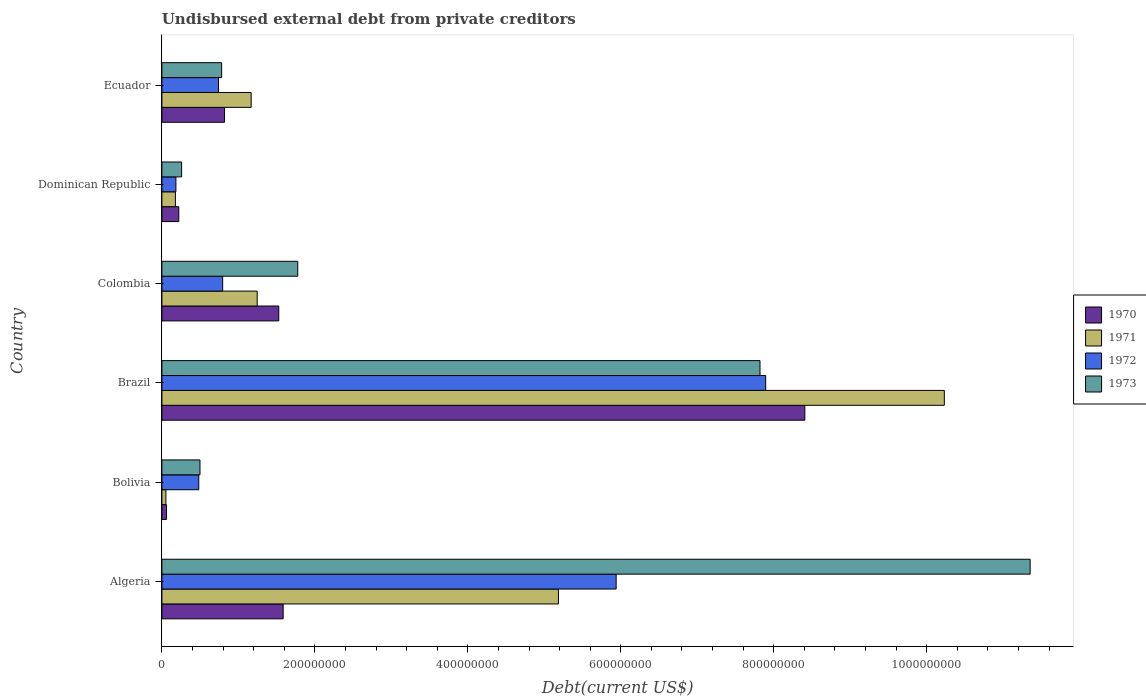Are the number of bars on each tick of the Y-axis equal?
Give a very brief answer. Yes. How many bars are there on the 4th tick from the top?
Make the answer very short. 4. What is the label of the 1st group of bars from the top?
Ensure brevity in your answer.  Ecuador. What is the total debt in 1972 in Dominican Republic?
Your answer should be compact. 1.83e+07. Across all countries, what is the maximum total debt in 1973?
Provide a short and direct response. 1.14e+09. Across all countries, what is the minimum total debt in 1970?
Ensure brevity in your answer.  6.05e+06. In which country was the total debt in 1973 maximum?
Make the answer very short. Algeria. In which country was the total debt in 1973 minimum?
Keep it short and to the point. Dominican Republic. What is the total total debt in 1973 in the graph?
Your response must be concise. 2.25e+09. What is the difference between the total debt in 1973 in Brazil and that in Colombia?
Make the answer very short. 6.04e+08. What is the difference between the total debt in 1973 in Ecuador and the total debt in 1972 in Algeria?
Make the answer very short. -5.16e+08. What is the average total debt in 1970 per country?
Provide a succinct answer. 2.10e+08. What is the difference between the total debt in 1972 and total debt in 1973 in Algeria?
Provide a succinct answer. -5.41e+08. In how many countries, is the total debt in 1972 greater than 240000000 US$?
Your answer should be compact. 2. What is the ratio of the total debt in 1973 in Brazil to that in Dominican Republic?
Give a very brief answer. 30.34. Is the total debt in 1970 in Brazil less than that in Ecuador?
Keep it short and to the point. No. What is the difference between the highest and the second highest total debt in 1971?
Provide a short and direct response. 5.05e+08. What is the difference between the highest and the lowest total debt in 1970?
Provide a short and direct response. 8.35e+08. Is the sum of the total debt in 1972 in Colombia and Dominican Republic greater than the maximum total debt in 1970 across all countries?
Offer a very short reply. No. Is it the case that in every country, the sum of the total debt in 1970 and total debt in 1971 is greater than the sum of total debt in 1972 and total debt in 1973?
Your answer should be compact. No. What does the 3rd bar from the top in Algeria represents?
Give a very brief answer. 1971. How many bars are there?
Ensure brevity in your answer.  24. Are all the bars in the graph horizontal?
Your response must be concise. Yes. How many countries are there in the graph?
Your answer should be compact. 6. Are the values on the major ticks of X-axis written in scientific E-notation?
Offer a very short reply. No. Does the graph contain any zero values?
Your answer should be very brief. No. Does the graph contain grids?
Your response must be concise. No. Where does the legend appear in the graph?
Your response must be concise. Center right. What is the title of the graph?
Provide a short and direct response. Undisbursed external debt from private creditors. What is the label or title of the X-axis?
Ensure brevity in your answer.  Debt(current US$). What is the label or title of the Y-axis?
Provide a short and direct response. Country. What is the Debt(current US$) of 1970 in Algeria?
Provide a succinct answer. 1.59e+08. What is the Debt(current US$) in 1971 in Algeria?
Provide a succinct answer. 5.18e+08. What is the Debt(current US$) of 1972 in Algeria?
Make the answer very short. 5.94e+08. What is the Debt(current US$) of 1973 in Algeria?
Offer a terse response. 1.14e+09. What is the Debt(current US$) in 1970 in Bolivia?
Provide a short and direct response. 6.05e+06. What is the Debt(current US$) of 1971 in Bolivia?
Offer a very short reply. 5.25e+06. What is the Debt(current US$) in 1972 in Bolivia?
Keep it short and to the point. 4.82e+07. What is the Debt(current US$) of 1973 in Bolivia?
Make the answer very short. 4.98e+07. What is the Debt(current US$) of 1970 in Brazil?
Offer a terse response. 8.41e+08. What is the Debt(current US$) of 1971 in Brazil?
Offer a terse response. 1.02e+09. What is the Debt(current US$) in 1972 in Brazil?
Ensure brevity in your answer.  7.89e+08. What is the Debt(current US$) in 1973 in Brazil?
Provide a short and direct response. 7.82e+08. What is the Debt(current US$) of 1970 in Colombia?
Your answer should be very brief. 1.53e+08. What is the Debt(current US$) of 1971 in Colombia?
Offer a very short reply. 1.25e+08. What is the Debt(current US$) of 1972 in Colombia?
Make the answer very short. 7.95e+07. What is the Debt(current US$) of 1973 in Colombia?
Provide a succinct answer. 1.78e+08. What is the Debt(current US$) in 1970 in Dominican Republic?
Your answer should be compact. 2.21e+07. What is the Debt(current US$) of 1971 in Dominican Republic?
Provide a succinct answer. 1.76e+07. What is the Debt(current US$) in 1972 in Dominican Republic?
Offer a very short reply. 1.83e+07. What is the Debt(current US$) of 1973 in Dominican Republic?
Give a very brief answer. 2.58e+07. What is the Debt(current US$) of 1970 in Ecuador?
Your answer should be compact. 8.19e+07. What is the Debt(current US$) of 1971 in Ecuador?
Ensure brevity in your answer.  1.17e+08. What is the Debt(current US$) of 1972 in Ecuador?
Provide a short and direct response. 7.40e+07. What is the Debt(current US$) in 1973 in Ecuador?
Make the answer very short. 7.81e+07. Across all countries, what is the maximum Debt(current US$) in 1970?
Offer a terse response. 8.41e+08. Across all countries, what is the maximum Debt(current US$) of 1971?
Keep it short and to the point. 1.02e+09. Across all countries, what is the maximum Debt(current US$) of 1972?
Ensure brevity in your answer.  7.89e+08. Across all countries, what is the maximum Debt(current US$) in 1973?
Give a very brief answer. 1.14e+09. Across all countries, what is the minimum Debt(current US$) in 1970?
Offer a terse response. 6.05e+06. Across all countries, what is the minimum Debt(current US$) of 1971?
Give a very brief answer. 5.25e+06. Across all countries, what is the minimum Debt(current US$) of 1972?
Your response must be concise. 1.83e+07. Across all countries, what is the minimum Debt(current US$) in 1973?
Give a very brief answer. 2.58e+07. What is the total Debt(current US$) in 1970 in the graph?
Your answer should be very brief. 1.26e+09. What is the total Debt(current US$) in 1971 in the graph?
Offer a very short reply. 1.81e+09. What is the total Debt(current US$) of 1972 in the graph?
Make the answer very short. 1.60e+09. What is the total Debt(current US$) in 1973 in the graph?
Offer a terse response. 2.25e+09. What is the difference between the Debt(current US$) in 1970 in Algeria and that in Bolivia?
Offer a very short reply. 1.53e+08. What is the difference between the Debt(current US$) in 1971 in Algeria and that in Bolivia?
Give a very brief answer. 5.13e+08. What is the difference between the Debt(current US$) of 1972 in Algeria and that in Bolivia?
Provide a short and direct response. 5.46e+08. What is the difference between the Debt(current US$) of 1973 in Algeria and that in Bolivia?
Your answer should be very brief. 1.09e+09. What is the difference between the Debt(current US$) in 1970 in Algeria and that in Brazil?
Ensure brevity in your answer.  -6.82e+08. What is the difference between the Debt(current US$) of 1971 in Algeria and that in Brazil?
Give a very brief answer. -5.05e+08. What is the difference between the Debt(current US$) in 1972 in Algeria and that in Brazil?
Provide a succinct answer. -1.95e+08. What is the difference between the Debt(current US$) of 1973 in Algeria and that in Brazil?
Offer a very short reply. 3.53e+08. What is the difference between the Debt(current US$) of 1970 in Algeria and that in Colombia?
Your response must be concise. 5.77e+06. What is the difference between the Debt(current US$) of 1971 in Algeria and that in Colombia?
Offer a terse response. 3.94e+08. What is the difference between the Debt(current US$) of 1972 in Algeria and that in Colombia?
Ensure brevity in your answer.  5.14e+08. What is the difference between the Debt(current US$) of 1973 in Algeria and that in Colombia?
Your response must be concise. 9.58e+08. What is the difference between the Debt(current US$) of 1970 in Algeria and that in Dominican Republic?
Give a very brief answer. 1.36e+08. What is the difference between the Debt(current US$) in 1971 in Algeria and that in Dominican Republic?
Your answer should be compact. 5.01e+08. What is the difference between the Debt(current US$) in 1972 in Algeria and that in Dominican Republic?
Offer a very short reply. 5.76e+08. What is the difference between the Debt(current US$) in 1973 in Algeria and that in Dominican Republic?
Keep it short and to the point. 1.11e+09. What is the difference between the Debt(current US$) of 1970 in Algeria and that in Ecuador?
Keep it short and to the point. 7.67e+07. What is the difference between the Debt(current US$) of 1971 in Algeria and that in Ecuador?
Offer a terse response. 4.02e+08. What is the difference between the Debt(current US$) in 1972 in Algeria and that in Ecuador?
Provide a succinct answer. 5.20e+08. What is the difference between the Debt(current US$) in 1973 in Algeria and that in Ecuador?
Offer a terse response. 1.06e+09. What is the difference between the Debt(current US$) in 1970 in Bolivia and that in Brazil?
Provide a succinct answer. -8.35e+08. What is the difference between the Debt(current US$) of 1971 in Bolivia and that in Brazil?
Ensure brevity in your answer.  -1.02e+09. What is the difference between the Debt(current US$) of 1972 in Bolivia and that in Brazil?
Give a very brief answer. -7.41e+08. What is the difference between the Debt(current US$) in 1973 in Bolivia and that in Brazil?
Your answer should be compact. -7.32e+08. What is the difference between the Debt(current US$) in 1970 in Bolivia and that in Colombia?
Your answer should be compact. -1.47e+08. What is the difference between the Debt(current US$) in 1971 in Bolivia and that in Colombia?
Provide a succinct answer. -1.19e+08. What is the difference between the Debt(current US$) in 1972 in Bolivia and that in Colombia?
Keep it short and to the point. -3.13e+07. What is the difference between the Debt(current US$) of 1973 in Bolivia and that in Colombia?
Make the answer very short. -1.28e+08. What is the difference between the Debt(current US$) of 1970 in Bolivia and that in Dominican Republic?
Your answer should be very brief. -1.60e+07. What is the difference between the Debt(current US$) of 1971 in Bolivia and that in Dominican Republic?
Give a very brief answer. -1.24e+07. What is the difference between the Debt(current US$) in 1972 in Bolivia and that in Dominican Republic?
Offer a very short reply. 2.99e+07. What is the difference between the Debt(current US$) of 1973 in Bolivia and that in Dominican Republic?
Provide a succinct answer. 2.40e+07. What is the difference between the Debt(current US$) in 1970 in Bolivia and that in Ecuador?
Your answer should be very brief. -7.58e+07. What is the difference between the Debt(current US$) of 1971 in Bolivia and that in Ecuador?
Offer a very short reply. -1.11e+08. What is the difference between the Debt(current US$) of 1972 in Bolivia and that in Ecuador?
Your response must be concise. -2.58e+07. What is the difference between the Debt(current US$) of 1973 in Bolivia and that in Ecuador?
Ensure brevity in your answer.  -2.83e+07. What is the difference between the Debt(current US$) of 1970 in Brazil and that in Colombia?
Your response must be concise. 6.88e+08. What is the difference between the Debt(current US$) in 1971 in Brazil and that in Colombia?
Provide a short and direct response. 8.98e+08. What is the difference between the Debt(current US$) in 1972 in Brazil and that in Colombia?
Your answer should be compact. 7.10e+08. What is the difference between the Debt(current US$) of 1973 in Brazil and that in Colombia?
Provide a succinct answer. 6.04e+08. What is the difference between the Debt(current US$) in 1970 in Brazil and that in Dominican Republic?
Give a very brief answer. 8.19e+08. What is the difference between the Debt(current US$) in 1971 in Brazil and that in Dominican Republic?
Your answer should be very brief. 1.01e+09. What is the difference between the Debt(current US$) in 1972 in Brazil and that in Dominican Republic?
Your answer should be compact. 7.71e+08. What is the difference between the Debt(current US$) in 1973 in Brazil and that in Dominican Republic?
Offer a very short reply. 7.56e+08. What is the difference between the Debt(current US$) in 1970 in Brazil and that in Ecuador?
Your answer should be compact. 7.59e+08. What is the difference between the Debt(current US$) of 1971 in Brazil and that in Ecuador?
Give a very brief answer. 9.06e+08. What is the difference between the Debt(current US$) of 1972 in Brazil and that in Ecuador?
Provide a succinct answer. 7.15e+08. What is the difference between the Debt(current US$) of 1973 in Brazil and that in Ecuador?
Your answer should be very brief. 7.04e+08. What is the difference between the Debt(current US$) in 1970 in Colombia and that in Dominican Republic?
Your response must be concise. 1.31e+08. What is the difference between the Debt(current US$) in 1971 in Colombia and that in Dominican Republic?
Keep it short and to the point. 1.07e+08. What is the difference between the Debt(current US$) of 1972 in Colombia and that in Dominican Republic?
Your response must be concise. 6.12e+07. What is the difference between the Debt(current US$) in 1973 in Colombia and that in Dominican Republic?
Keep it short and to the point. 1.52e+08. What is the difference between the Debt(current US$) in 1970 in Colombia and that in Ecuador?
Your response must be concise. 7.09e+07. What is the difference between the Debt(current US$) in 1971 in Colombia and that in Ecuador?
Offer a terse response. 7.88e+06. What is the difference between the Debt(current US$) in 1972 in Colombia and that in Ecuador?
Your answer should be very brief. 5.49e+06. What is the difference between the Debt(current US$) of 1973 in Colombia and that in Ecuador?
Your response must be concise. 9.95e+07. What is the difference between the Debt(current US$) in 1970 in Dominican Republic and that in Ecuador?
Keep it short and to the point. -5.98e+07. What is the difference between the Debt(current US$) of 1971 in Dominican Republic and that in Ecuador?
Your response must be concise. -9.91e+07. What is the difference between the Debt(current US$) in 1972 in Dominican Republic and that in Ecuador?
Provide a succinct answer. -5.57e+07. What is the difference between the Debt(current US$) in 1973 in Dominican Republic and that in Ecuador?
Keep it short and to the point. -5.23e+07. What is the difference between the Debt(current US$) in 1970 in Algeria and the Debt(current US$) in 1971 in Bolivia?
Your answer should be very brief. 1.53e+08. What is the difference between the Debt(current US$) of 1970 in Algeria and the Debt(current US$) of 1972 in Bolivia?
Ensure brevity in your answer.  1.10e+08. What is the difference between the Debt(current US$) of 1970 in Algeria and the Debt(current US$) of 1973 in Bolivia?
Ensure brevity in your answer.  1.09e+08. What is the difference between the Debt(current US$) in 1971 in Algeria and the Debt(current US$) in 1972 in Bolivia?
Keep it short and to the point. 4.70e+08. What is the difference between the Debt(current US$) in 1971 in Algeria and the Debt(current US$) in 1973 in Bolivia?
Your answer should be very brief. 4.69e+08. What is the difference between the Debt(current US$) in 1972 in Algeria and the Debt(current US$) in 1973 in Bolivia?
Keep it short and to the point. 5.44e+08. What is the difference between the Debt(current US$) of 1970 in Algeria and the Debt(current US$) of 1971 in Brazil?
Offer a very short reply. -8.64e+08. What is the difference between the Debt(current US$) of 1970 in Algeria and the Debt(current US$) of 1972 in Brazil?
Offer a terse response. -6.31e+08. What is the difference between the Debt(current US$) of 1970 in Algeria and the Debt(current US$) of 1973 in Brazil?
Your answer should be compact. -6.23e+08. What is the difference between the Debt(current US$) of 1971 in Algeria and the Debt(current US$) of 1972 in Brazil?
Provide a short and direct response. -2.71e+08. What is the difference between the Debt(current US$) of 1971 in Algeria and the Debt(current US$) of 1973 in Brazil?
Ensure brevity in your answer.  -2.64e+08. What is the difference between the Debt(current US$) of 1972 in Algeria and the Debt(current US$) of 1973 in Brazil?
Ensure brevity in your answer.  -1.88e+08. What is the difference between the Debt(current US$) in 1970 in Algeria and the Debt(current US$) in 1971 in Colombia?
Offer a terse response. 3.40e+07. What is the difference between the Debt(current US$) in 1970 in Algeria and the Debt(current US$) in 1972 in Colombia?
Offer a very short reply. 7.91e+07. What is the difference between the Debt(current US$) in 1970 in Algeria and the Debt(current US$) in 1973 in Colombia?
Provide a short and direct response. -1.90e+07. What is the difference between the Debt(current US$) in 1971 in Algeria and the Debt(current US$) in 1972 in Colombia?
Provide a short and direct response. 4.39e+08. What is the difference between the Debt(current US$) of 1971 in Algeria and the Debt(current US$) of 1973 in Colombia?
Offer a very short reply. 3.41e+08. What is the difference between the Debt(current US$) in 1972 in Algeria and the Debt(current US$) in 1973 in Colombia?
Give a very brief answer. 4.16e+08. What is the difference between the Debt(current US$) of 1970 in Algeria and the Debt(current US$) of 1971 in Dominican Republic?
Keep it short and to the point. 1.41e+08. What is the difference between the Debt(current US$) of 1970 in Algeria and the Debt(current US$) of 1972 in Dominican Republic?
Offer a very short reply. 1.40e+08. What is the difference between the Debt(current US$) in 1970 in Algeria and the Debt(current US$) in 1973 in Dominican Republic?
Provide a short and direct response. 1.33e+08. What is the difference between the Debt(current US$) in 1971 in Algeria and the Debt(current US$) in 1972 in Dominican Republic?
Your response must be concise. 5.00e+08. What is the difference between the Debt(current US$) in 1971 in Algeria and the Debt(current US$) in 1973 in Dominican Republic?
Provide a short and direct response. 4.93e+08. What is the difference between the Debt(current US$) of 1972 in Algeria and the Debt(current US$) of 1973 in Dominican Republic?
Provide a short and direct response. 5.68e+08. What is the difference between the Debt(current US$) in 1970 in Algeria and the Debt(current US$) in 1971 in Ecuador?
Your answer should be compact. 4.18e+07. What is the difference between the Debt(current US$) of 1970 in Algeria and the Debt(current US$) of 1972 in Ecuador?
Provide a short and direct response. 8.46e+07. What is the difference between the Debt(current US$) in 1970 in Algeria and the Debt(current US$) in 1973 in Ecuador?
Your response must be concise. 8.05e+07. What is the difference between the Debt(current US$) in 1971 in Algeria and the Debt(current US$) in 1972 in Ecuador?
Ensure brevity in your answer.  4.44e+08. What is the difference between the Debt(current US$) in 1971 in Algeria and the Debt(current US$) in 1973 in Ecuador?
Offer a very short reply. 4.40e+08. What is the difference between the Debt(current US$) in 1972 in Algeria and the Debt(current US$) in 1973 in Ecuador?
Offer a terse response. 5.16e+08. What is the difference between the Debt(current US$) in 1970 in Bolivia and the Debt(current US$) in 1971 in Brazil?
Keep it short and to the point. -1.02e+09. What is the difference between the Debt(current US$) of 1970 in Bolivia and the Debt(current US$) of 1972 in Brazil?
Offer a very short reply. -7.83e+08. What is the difference between the Debt(current US$) in 1970 in Bolivia and the Debt(current US$) in 1973 in Brazil?
Give a very brief answer. -7.76e+08. What is the difference between the Debt(current US$) of 1971 in Bolivia and the Debt(current US$) of 1972 in Brazil?
Your response must be concise. -7.84e+08. What is the difference between the Debt(current US$) in 1971 in Bolivia and the Debt(current US$) in 1973 in Brazil?
Give a very brief answer. -7.77e+08. What is the difference between the Debt(current US$) in 1972 in Bolivia and the Debt(current US$) in 1973 in Brazil?
Provide a short and direct response. -7.34e+08. What is the difference between the Debt(current US$) of 1970 in Bolivia and the Debt(current US$) of 1971 in Colombia?
Your response must be concise. -1.19e+08. What is the difference between the Debt(current US$) in 1970 in Bolivia and the Debt(current US$) in 1972 in Colombia?
Offer a very short reply. -7.34e+07. What is the difference between the Debt(current US$) in 1970 in Bolivia and the Debt(current US$) in 1973 in Colombia?
Your response must be concise. -1.72e+08. What is the difference between the Debt(current US$) of 1971 in Bolivia and the Debt(current US$) of 1972 in Colombia?
Your answer should be compact. -7.42e+07. What is the difference between the Debt(current US$) of 1971 in Bolivia and the Debt(current US$) of 1973 in Colombia?
Offer a very short reply. -1.72e+08. What is the difference between the Debt(current US$) in 1972 in Bolivia and the Debt(current US$) in 1973 in Colombia?
Offer a terse response. -1.29e+08. What is the difference between the Debt(current US$) in 1970 in Bolivia and the Debt(current US$) in 1971 in Dominican Republic?
Provide a succinct answer. -1.16e+07. What is the difference between the Debt(current US$) of 1970 in Bolivia and the Debt(current US$) of 1972 in Dominican Republic?
Your answer should be very brief. -1.23e+07. What is the difference between the Debt(current US$) of 1970 in Bolivia and the Debt(current US$) of 1973 in Dominican Republic?
Ensure brevity in your answer.  -1.97e+07. What is the difference between the Debt(current US$) in 1971 in Bolivia and the Debt(current US$) in 1972 in Dominican Republic?
Your response must be concise. -1.31e+07. What is the difference between the Debt(current US$) of 1971 in Bolivia and the Debt(current US$) of 1973 in Dominican Republic?
Make the answer very short. -2.05e+07. What is the difference between the Debt(current US$) in 1972 in Bolivia and the Debt(current US$) in 1973 in Dominican Republic?
Keep it short and to the point. 2.24e+07. What is the difference between the Debt(current US$) in 1970 in Bolivia and the Debt(current US$) in 1971 in Ecuador?
Provide a succinct answer. -1.11e+08. What is the difference between the Debt(current US$) of 1970 in Bolivia and the Debt(current US$) of 1972 in Ecuador?
Keep it short and to the point. -6.79e+07. What is the difference between the Debt(current US$) in 1970 in Bolivia and the Debt(current US$) in 1973 in Ecuador?
Your answer should be compact. -7.21e+07. What is the difference between the Debt(current US$) of 1971 in Bolivia and the Debt(current US$) of 1972 in Ecuador?
Your response must be concise. -6.87e+07. What is the difference between the Debt(current US$) of 1971 in Bolivia and the Debt(current US$) of 1973 in Ecuador?
Your response must be concise. -7.29e+07. What is the difference between the Debt(current US$) of 1972 in Bolivia and the Debt(current US$) of 1973 in Ecuador?
Your answer should be compact. -2.99e+07. What is the difference between the Debt(current US$) of 1970 in Brazil and the Debt(current US$) of 1971 in Colombia?
Your answer should be very brief. 7.16e+08. What is the difference between the Debt(current US$) of 1970 in Brazil and the Debt(current US$) of 1972 in Colombia?
Your answer should be compact. 7.61e+08. What is the difference between the Debt(current US$) of 1970 in Brazil and the Debt(current US$) of 1973 in Colombia?
Provide a short and direct response. 6.63e+08. What is the difference between the Debt(current US$) of 1971 in Brazil and the Debt(current US$) of 1972 in Colombia?
Offer a very short reply. 9.44e+08. What is the difference between the Debt(current US$) of 1971 in Brazil and the Debt(current US$) of 1973 in Colombia?
Offer a very short reply. 8.45e+08. What is the difference between the Debt(current US$) of 1972 in Brazil and the Debt(current US$) of 1973 in Colombia?
Offer a terse response. 6.12e+08. What is the difference between the Debt(current US$) in 1970 in Brazil and the Debt(current US$) in 1971 in Dominican Republic?
Offer a very short reply. 8.23e+08. What is the difference between the Debt(current US$) in 1970 in Brazil and the Debt(current US$) in 1972 in Dominican Republic?
Offer a terse response. 8.22e+08. What is the difference between the Debt(current US$) in 1970 in Brazil and the Debt(current US$) in 1973 in Dominican Republic?
Provide a succinct answer. 8.15e+08. What is the difference between the Debt(current US$) in 1971 in Brazil and the Debt(current US$) in 1972 in Dominican Republic?
Offer a very short reply. 1.00e+09. What is the difference between the Debt(current US$) in 1971 in Brazil and the Debt(current US$) in 1973 in Dominican Republic?
Provide a short and direct response. 9.97e+08. What is the difference between the Debt(current US$) of 1972 in Brazil and the Debt(current US$) of 1973 in Dominican Republic?
Offer a very short reply. 7.64e+08. What is the difference between the Debt(current US$) in 1970 in Brazil and the Debt(current US$) in 1971 in Ecuador?
Provide a short and direct response. 7.24e+08. What is the difference between the Debt(current US$) of 1970 in Brazil and the Debt(current US$) of 1972 in Ecuador?
Your answer should be very brief. 7.67e+08. What is the difference between the Debt(current US$) in 1970 in Brazil and the Debt(current US$) in 1973 in Ecuador?
Provide a succinct answer. 7.63e+08. What is the difference between the Debt(current US$) of 1971 in Brazil and the Debt(current US$) of 1972 in Ecuador?
Ensure brevity in your answer.  9.49e+08. What is the difference between the Debt(current US$) of 1971 in Brazil and the Debt(current US$) of 1973 in Ecuador?
Ensure brevity in your answer.  9.45e+08. What is the difference between the Debt(current US$) of 1972 in Brazil and the Debt(current US$) of 1973 in Ecuador?
Your answer should be compact. 7.11e+08. What is the difference between the Debt(current US$) of 1970 in Colombia and the Debt(current US$) of 1971 in Dominican Republic?
Your answer should be very brief. 1.35e+08. What is the difference between the Debt(current US$) in 1970 in Colombia and the Debt(current US$) in 1972 in Dominican Republic?
Offer a terse response. 1.34e+08. What is the difference between the Debt(current US$) of 1970 in Colombia and the Debt(current US$) of 1973 in Dominican Republic?
Keep it short and to the point. 1.27e+08. What is the difference between the Debt(current US$) in 1971 in Colombia and the Debt(current US$) in 1972 in Dominican Republic?
Keep it short and to the point. 1.06e+08. What is the difference between the Debt(current US$) in 1971 in Colombia and the Debt(current US$) in 1973 in Dominican Republic?
Offer a very short reply. 9.88e+07. What is the difference between the Debt(current US$) in 1972 in Colombia and the Debt(current US$) in 1973 in Dominican Republic?
Offer a terse response. 5.37e+07. What is the difference between the Debt(current US$) of 1970 in Colombia and the Debt(current US$) of 1971 in Ecuador?
Ensure brevity in your answer.  3.61e+07. What is the difference between the Debt(current US$) of 1970 in Colombia and the Debt(current US$) of 1972 in Ecuador?
Offer a terse response. 7.88e+07. What is the difference between the Debt(current US$) in 1970 in Colombia and the Debt(current US$) in 1973 in Ecuador?
Offer a terse response. 7.47e+07. What is the difference between the Debt(current US$) of 1971 in Colombia and the Debt(current US$) of 1972 in Ecuador?
Offer a terse response. 5.06e+07. What is the difference between the Debt(current US$) in 1971 in Colombia and the Debt(current US$) in 1973 in Ecuador?
Keep it short and to the point. 4.65e+07. What is the difference between the Debt(current US$) in 1972 in Colombia and the Debt(current US$) in 1973 in Ecuador?
Keep it short and to the point. 1.36e+06. What is the difference between the Debt(current US$) in 1970 in Dominican Republic and the Debt(current US$) in 1971 in Ecuador?
Your response must be concise. -9.46e+07. What is the difference between the Debt(current US$) of 1970 in Dominican Republic and the Debt(current US$) of 1972 in Ecuador?
Make the answer very short. -5.19e+07. What is the difference between the Debt(current US$) in 1970 in Dominican Republic and the Debt(current US$) in 1973 in Ecuador?
Make the answer very short. -5.60e+07. What is the difference between the Debt(current US$) of 1971 in Dominican Republic and the Debt(current US$) of 1972 in Ecuador?
Your answer should be compact. -5.63e+07. What is the difference between the Debt(current US$) in 1971 in Dominican Republic and the Debt(current US$) in 1973 in Ecuador?
Offer a very short reply. -6.05e+07. What is the difference between the Debt(current US$) in 1972 in Dominican Republic and the Debt(current US$) in 1973 in Ecuador?
Provide a succinct answer. -5.98e+07. What is the average Debt(current US$) in 1970 per country?
Offer a terse response. 2.10e+08. What is the average Debt(current US$) of 1971 per country?
Provide a short and direct response. 3.01e+08. What is the average Debt(current US$) in 1972 per country?
Provide a succinct answer. 2.67e+08. What is the average Debt(current US$) in 1973 per country?
Make the answer very short. 3.75e+08. What is the difference between the Debt(current US$) in 1970 and Debt(current US$) in 1971 in Algeria?
Keep it short and to the point. -3.60e+08. What is the difference between the Debt(current US$) in 1970 and Debt(current US$) in 1972 in Algeria?
Your answer should be compact. -4.35e+08. What is the difference between the Debt(current US$) in 1970 and Debt(current US$) in 1973 in Algeria?
Your answer should be very brief. -9.77e+08. What is the difference between the Debt(current US$) of 1971 and Debt(current US$) of 1972 in Algeria?
Give a very brief answer. -7.55e+07. What is the difference between the Debt(current US$) of 1971 and Debt(current US$) of 1973 in Algeria?
Your answer should be very brief. -6.17e+08. What is the difference between the Debt(current US$) of 1972 and Debt(current US$) of 1973 in Algeria?
Offer a terse response. -5.41e+08. What is the difference between the Debt(current US$) in 1970 and Debt(current US$) in 1971 in Bolivia?
Keep it short and to the point. 8.02e+05. What is the difference between the Debt(current US$) in 1970 and Debt(current US$) in 1972 in Bolivia?
Make the answer very short. -4.22e+07. What is the difference between the Debt(current US$) of 1970 and Debt(current US$) of 1973 in Bolivia?
Give a very brief answer. -4.37e+07. What is the difference between the Debt(current US$) in 1971 and Debt(current US$) in 1972 in Bolivia?
Your answer should be very brief. -4.30e+07. What is the difference between the Debt(current US$) in 1971 and Debt(current US$) in 1973 in Bolivia?
Ensure brevity in your answer.  -4.45e+07. What is the difference between the Debt(current US$) in 1972 and Debt(current US$) in 1973 in Bolivia?
Ensure brevity in your answer.  -1.58e+06. What is the difference between the Debt(current US$) in 1970 and Debt(current US$) in 1971 in Brazil?
Your answer should be compact. -1.82e+08. What is the difference between the Debt(current US$) of 1970 and Debt(current US$) of 1972 in Brazil?
Offer a terse response. 5.12e+07. What is the difference between the Debt(current US$) of 1970 and Debt(current US$) of 1973 in Brazil?
Make the answer very short. 5.86e+07. What is the difference between the Debt(current US$) in 1971 and Debt(current US$) in 1972 in Brazil?
Offer a very short reply. 2.34e+08. What is the difference between the Debt(current US$) of 1971 and Debt(current US$) of 1973 in Brazil?
Give a very brief answer. 2.41e+08. What is the difference between the Debt(current US$) of 1972 and Debt(current US$) of 1973 in Brazil?
Make the answer very short. 7.41e+06. What is the difference between the Debt(current US$) in 1970 and Debt(current US$) in 1971 in Colombia?
Your answer should be compact. 2.82e+07. What is the difference between the Debt(current US$) in 1970 and Debt(current US$) in 1972 in Colombia?
Make the answer very short. 7.33e+07. What is the difference between the Debt(current US$) in 1970 and Debt(current US$) in 1973 in Colombia?
Ensure brevity in your answer.  -2.48e+07. What is the difference between the Debt(current US$) in 1971 and Debt(current US$) in 1972 in Colombia?
Provide a succinct answer. 4.51e+07. What is the difference between the Debt(current US$) of 1971 and Debt(current US$) of 1973 in Colombia?
Keep it short and to the point. -5.30e+07. What is the difference between the Debt(current US$) of 1972 and Debt(current US$) of 1973 in Colombia?
Your answer should be very brief. -9.81e+07. What is the difference between the Debt(current US$) of 1970 and Debt(current US$) of 1971 in Dominican Republic?
Provide a succinct answer. 4.46e+06. What is the difference between the Debt(current US$) in 1970 and Debt(current US$) in 1972 in Dominican Republic?
Provide a succinct answer. 3.78e+06. What is the difference between the Debt(current US$) in 1970 and Debt(current US$) in 1973 in Dominican Republic?
Your response must be concise. -3.68e+06. What is the difference between the Debt(current US$) in 1971 and Debt(current US$) in 1972 in Dominican Republic?
Give a very brief answer. -6.84e+05. What is the difference between the Debt(current US$) of 1971 and Debt(current US$) of 1973 in Dominican Republic?
Offer a terse response. -8.14e+06. What is the difference between the Debt(current US$) in 1972 and Debt(current US$) in 1973 in Dominican Republic?
Provide a succinct answer. -7.46e+06. What is the difference between the Debt(current US$) in 1970 and Debt(current US$) in 1971 in Ecuador?
Provide a succinct answer. -3.48e+07. What is the difference between the Debt(current US$) in 1970 and Debt(current US$) in 1972 in Ecuador?
Make the answer very short. 7.92e+06. What is the difference between the Debt(current US$) in 1970 and Debt(current US$) in 1973 in Ecuador?
Keep it short and to the point. 3.78e+06. What is the difference between the Debt(current US$) of 1971 and Debt(current US$) of 1972 in Ecuador?
Ensure brevity in your answer.  4.27e+07. What is the difference between the Debt(current US$) in 1971 and Debt(current US$) in 1973 in Ecuador?
Your response must be concise. 3.86e+07. What is the difference between the Debt(current US$) of 1972 and Debt(current US$) of 1973 in Ecuador?
Your answer should be compact. -4.14e+06. What is the ratio of the Debt(current US$) of 1970 in Algeria to that in Bolivia?
Keep it short and to the point. 26.22. What is the ratio of the Debt(current US$) in 1971 in Algeria to that in Bolivia?
Make the answer very short. 98.83. What is the ratio of the Debt(current US$) in 1972 in Algeria to that in Bolivia?
Give a very brief answer. 12.32. What is the ratio of the Debt(current US$) in 1973 in Algeria to that in Bolivia?
Provide a short and direct response. 22.8. What is the ratio of the Debt(current US$) of 1970 in Algeria to that in Brazil?
Offer a terse response. 0.19. What is the ratio of the Debt(current US$) in 1971 in Algeria to that in Brazil?
Offer a very short reply. 0.51. What is the ratio of the Debt(current US$) in 1972 in Algeria to that in Brazil?
Your response must be concise. 0.75. What is the ratio of the Debt(current US$) of 1973 in Algeria to that in Brazil?
Your answer should be compact. 1.45. What is the ratio of the Debt(current US$) of 1970 in Algeria to that in Colombia?
Your answer should be compact. 1.04. What is the ratio of the Debt(current US$) of 1971 in Algeria to that in Colombia?
Your response must be concise. 4.16. What is the ratio of the Debt(current US$) in 1972 in Algeria to that in Colombia?
Offer a very short reply. 7.47. What is the ratio of the Debt(current US$) of 1973 in Algeria to that in Colombia?
Provide a succinct answer. 6.39. What is the ratio of the Debt(current US$) of 1970 in Algeria to that in Dominican Republic?
Offer a terse response. 7.18. What is the ratio of the Debt(current US$) in 1971 in Algeria to that in Dominican Republic?
Keep it short and to the point. 29.4. What is the ratio of the Debt(current US$) of 1972 in Algeria to that in Dominican Republic?
Your answer should be compact. 32.43. What is the ratio of the Debt(current US$) of 1973 in Algeria to that in Dominican Republic?
Your response must be concise. 44.05. What is the ratio of the Debt(current US$) of 1970 in Algeria to that in Ecuador?
Give a very brief answer. 1.94. What is the ratio of the Debt(current US$) of 1971 in Algeria to that in Ecuador?
Provide a succinct answer. 4.44. What is the ratio of the Debt(current US$) in 1972 in Algeria to that in Ecuador?
Provide a short and direct response. 8.03. What is the ratio of the Debt(current US$) in 1973 in Algeria to that in Ecuador?
Give a very brief answer. 14.53. What is the ratio of the Debt(current US$) of 1970 in Bolivia to that in Brazil?
Give a very brief answer. 0.01. What is the ratio of the Debt(current US$) of 1971 in Bolivia to that in Brazil?
Make the answer very short. 0.01. What is the ratio of the Debt(current US$) of 1972 in Bolivia to that in Brazil?
Offer a terse response. 0.06. What is the ratio of the Debt(current US$) in 1973 in Bolivia to that in Brazil?
Your response must be concise. 0.06. What is the ratio of the Debt(current US$) of 1970 in Bolivia to that in Colombia?
Your response must be concise. 0.04. What is the ratio of the Debt(current US$) of 1971 in Bolivia to that in Colombia?
Ensure brevity in your answer.  0.04. What is the ratio of the Debt(current US$) in 1972 in Bolivia to that in Colombia?
Offer a terse response. 0.61. What is the ratio of the Debt(current US$) of 1973 in Bolivia to that in Colombia?
Give a very brief answer. 0.28. What is the ratio of the Debt(current US$) in 1970 in Bolivia to that in Dominican Republic?
Ensure brevity in your answer.  0.27. What is the ratio of the Debt(current US$) of 1971 in Bolivia to that in Dominican Republic?
Provide a succinct answer. 0.3. What is the ratio of the Debt(current US$) of 1972 in Bolivia to that in Dominican Republic?
Your answer should be very brief. 2.63. What is the ratio of the Debt(current US$) in 1973 in Bolivia to that in Dominican Republic?
Provide a short and direct response. 1.93. What is the ratio of the Debt(current US$) of 1970 in Bolivia to that in Ecuador?
Provide a short and direct response. 0.07. What is the ratio of the Debt(current US$) of 1971 in Bolivia to that in Ecuador?
Your response must be concise. 0.04. What is the ratio of the Debt(current US$) in 1972 in Bolivia to that in Ecuador?
Give a very brief answer. 0.65. What is the ratio of the Debt(current US$) in 1973 in Bolivia to that in Ecuador?
Provide a short and direct response. 0.64. What is the ratio of the Debt(current US$) in 1970 in Brazil to that in Colombia?
Provide a short and direct response. 5.5. What is the ratio of the Debt(current US$) in 1971 in Brazil to that in Colombia?
Give a very brief answer. 8.21. What is the ratio of the Debt(current US$) of 1972 in Brazil to that in Colombia?
Offer a very short reply. 9.93. What is the ratio of the Debt(current US$) of 1973 in Brazil to that in Colombia?
Keep it short and to the point. 4.4. What is the ratio of the Debt(current US$) in 1970 in Brazil to that in Dominican Republic?
Make the answer very short. 38.04. What is the ratio of the Debt(current US$) in 1971 in Brazil to that in Dominican Republic?
Your response must be concise. 58.02. What is the ratio of the Debt(current US$) of 1972 in Brazil to that in Dominican Republic?
Make the answer very short. 43.1. What is the ratio of the Debt(current US$) of 1973 in Brazil to that in Dominican Republic?
Provide a succinct answer. 30.34. What is the ratio of the Debt(current US$) of 1970 in Brazil to that in Ecuador?
Give a very brief answer. 10.26. What is the ratio of the Debt(current US$) of 1971 in Brazil to that in Ecuador?
Give a very brief answer. 8.76. What is the ratio of the Debt(current US$) of 1972 in Brazil to that in Ecuador?
Your answer should be compact. 10.67. What is the ratio of the Debt(current US$) of 1973 in Brazil to that in Ecuador?
Offer a terse response. 10.01. What is the ratio of the Debt(current US$) of 1970 in Colombia to that in Dominican Republic?
Offer a very short reply. 6.92. What is the ratio of the Debt(current US$) of 1971 in Colombia to that in Dominican Republic?
Provide a short and direct response. 7.07. What is the ratio of the Debt(current US$) in 1972 in Colombia to that in Dominican Republic?
Provide a succinct answer. 4.34. What is the ratio of the Debt(current US$) in 1973 in Colombia to that in Dominican Republic?
Offer a terse response. 6.89. What is the ratio of the Debt(current US$) in 1970 in Colombia to that in Ecuador?
Keep it short and to the point. 1.87. What is the ratio of the Debt(current US$) in 1971 in Colombia to that in Ecuador?
Your answer should be compact. 1.07. What is the ratio of the Debt(current US$) of 1972 in Colombia to that in Ecuador?
Your answer should be very brief. 1.07. What is the ratio of the Debt(current US$) of 1973 in Colombia to that in Ecuador?
Ensure brevity in your answer.  2.27. What is the ratio of the Debt(current US$) in 1970 in Dominican Republic to that in Ecuador?
Your response must be concise. 0.27. What is the ratio of the Debt(current US$) of 1971 in Dominican Republic to that in Ecuador?
Ensure brevity in your answer.  0.15. What is the ratio of the Debt(current US$) in 1972 in Dominican Republic to that in Ecuador?
Provide a short and direct response. 0.25. What is the ratio of the Debt(current US$) of 1973 in Dominican Republic to that in Ecuador?
Offer a very short reply. 0.33. What is the difference between the highest and the second highest Debt(current US$) in 1970?
Ensure brevity in your answer.  6.82e+08. What is the difference between the highest and the second highest Debt(current US$) in 1971?
Offer a terse response. 5.05e+08. What is the difference between the highest and the second highest Debt(current US$) in 1972?
Your response must be concise. 1.95e+08. What is the difference between the highest and the second highest Debt(current US$) of 1973?
Ensure brevity in your answer.  3.53e+08. What is the difference between the highest and the lowest Debt(current US$) of 1970?
Your answer should be compact. 8.35e+08. What is the difference between the highest and the lowest Debt(current US$) of 1971?
Give a very brief answer. 1.02e+09. What is the difference between the highest and the lowest Debt(current US$) in 1972?
Your response must be concise. 7.71e+08. What is the difference between the highest and the lowest Debt(current US$) of 1973?
Keep it short and to the point. 1.11e+09. 